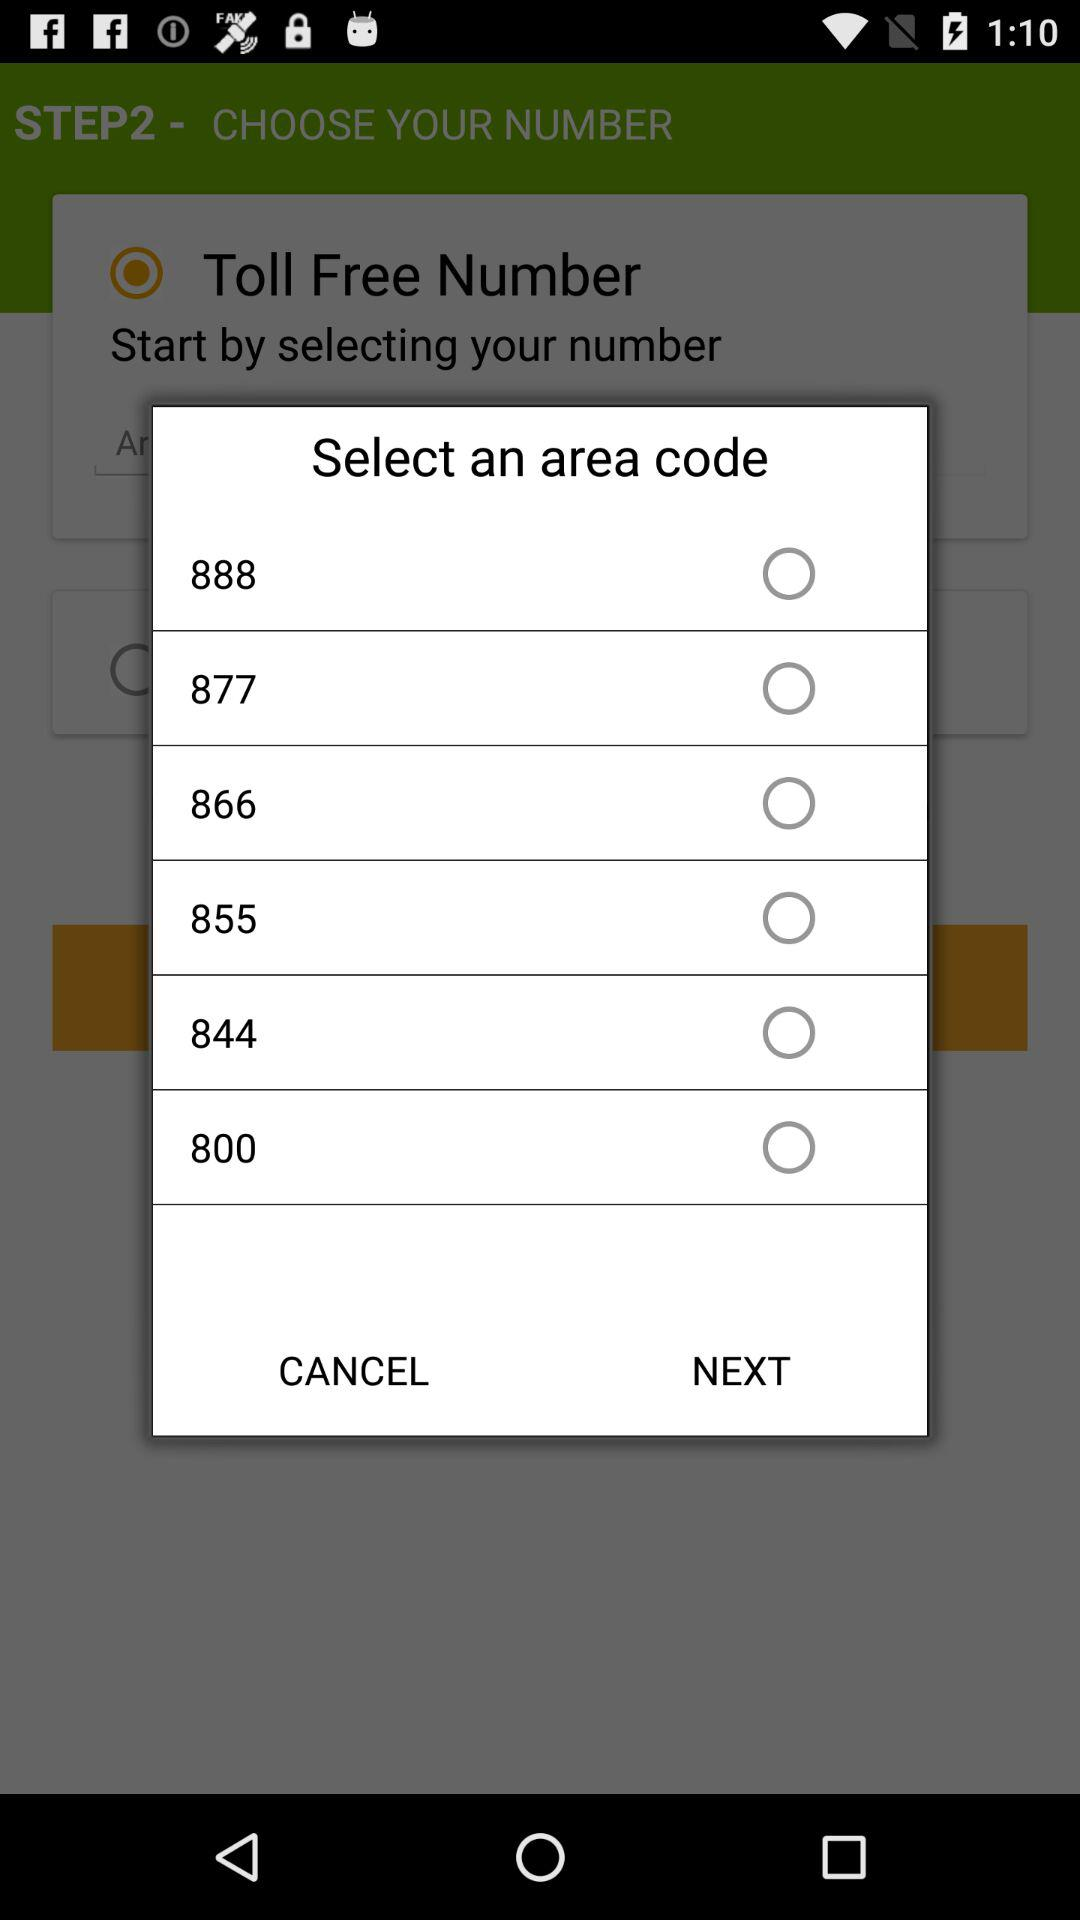How many area codes are available?
Answer the question using a single word or phrase. 6 